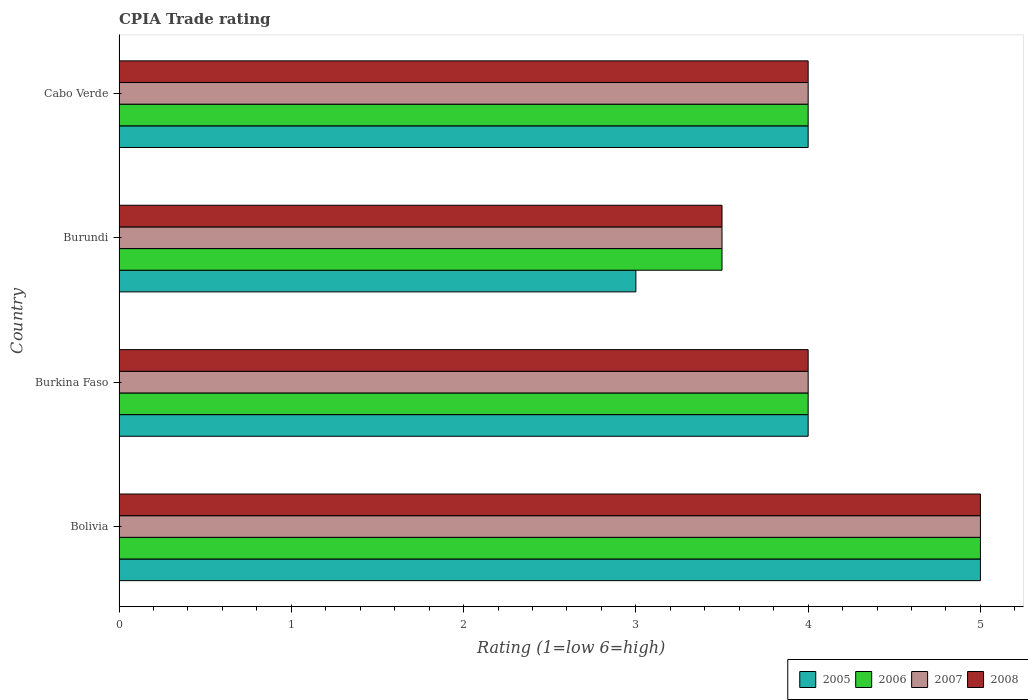How many groups of bars are there?
Ensure brevity in your answer.  4. Are the number of bars on each tick of the Y-axis equal?
Keep it short and to the point. Yes. How many bars are there on the 2nd tick from the bottom?
Offer a terse response. 4. What is the label of the 4th group of bars from the top?
Give a very brief answer. Bolivia. Across all countries, what is the minimum CPIA rating in 2005?
Give a very brief answer. 3. In which country was the CPIA rating in 2005 maximum?
Ensure brevity in your answer.  Bolivia. In which country was the CPIA rating in 2005 minimum?
Ensure brevity in your answer.  Burundi. What is the total CPIA rating in 2006 in the graph?
Offer a very short reply. 16.5. What is the difference between the CPIA rating in 2007 in Burkina Faso and that in Cabo Verde?
Provide a short and direct response. 0. What is the difference between the CPIA rating in 2005 in Bolivia and the CPIA rating in 2006 in Burkina Faso?
Your answer should be very brief. 1. What is the difference between the CPIA rating in 2007 and CPIA rating in 2006 in Bolivia?
Offer a terse response. 0. What is the ratio of the CPIA rating in 2007 in Burundi to that in Cabo Verde?
Your answer should be very brief. 0.88. Is the CPIA rating in 2007 in Burundi less than that in Cabo Verde?
Your response must be concise. Yes. What is the difference between the highest and the lowest CPIA rating in 2006?
Provide a succinct answer. 1.5. In how many countries, is the CPIA rating in 2007 greater than the average CPIA rating in 2007 taken over all countries?
Provide a short and direct response. 1. What does the 3rd bar from the bottom in Cabo Verde represents?
Your answer should be very brief. 2007. How many bars are there?
Your answer should be compact. 16. Are all the bars in the graph horizontal?
Make the answer very short. Yes. How many countries are there in the graph?
Keep it short and to the point. 4. What is the difference between two consecutive major ticks on the X-axis?
Give a very brief answer. 1. What is the title of the graph?
Offer a terse response. CPIA Trade rating. What is the label or title of the X-axis?
Your response must be concise. Rating (1=low 6=high). What is the label or title of the Y-axis?
Give a very brief answer. Country. What is the Rating (1=low 6=high) in 2005 in Burkina Faso?
Give a very brief answer. 4. What is the Rating (1=low 6=high) of 2005 in Burundi?
Give a very brief answer. 3. What is the Rating (1=low 6=high) in 2007 in Burundi?
Your answer should be compact. 3.5. What is the Rating (1=low 6=high) of 2008 in Burundi?
Your response must be concise. 3.5. What is the Rating (1=low 6=high) of 2005 in Cabo Verde?
Offer a very short reply. 4. Across all countries, what is the maximum Rating (1=low 6=high) in 2005?
Offer a terse response. 5. Across all countries, what is the maximum Rating (1=low 6=high) of 2007?
Provide a succinct answer. 5. Across all countries, what is the minimum Rating (1=low 6=high) of 2005?
Provide a succinct answer. 3. What is the total Rating (1=low 6=high) of 2007 in the graph?
Your response must be concise. 16.5. What is the total Rating (1=low 6=high) of 2008 in the graph?
Your response must be concise. 16.5. What is the difference between the Rating (1=low 6=high) of 2007 in Bolivia and that in Burkina Faso?
Your response must be concise. 1. What is the difference between the Rating (1=low 6=high) of 2005 in Bolivia and that in Burundi?
Offer a terse response. 2. What is the difference between the Rating (1=low 6=high) in 2007 in Bolivia and that in Burundi?
Keep it short and to the point. 1.5. What is the difference between the Rating (1=low 6=high) in 2007 in Bolivia and that in Cabo Verde?
Provide a succinct answer. 1. What is the difference between the Rating (1=low 6=high) of 2006 in Burkina Faso and that in Burundi?
Provide a succinct answer. 0.5. What is the difference between the Rating (1=low 6=high) in 2005 in Burundi and that in Cabo Verde?
Offer a very short reply. -1. What is the difference between the Rating (1=low 6=high) in 2006 in Burundi and that in Cabo Verde?
Your response must be concise. -0.5. What is the difference between the Rating (1=low 6=high) in 2007 in Burundi and that in Cabo Verde?
Offer a very short reply. -0.5. What is the difference between the Rating (1=low 6=high) in 2005 in Bolivia and the Rating (1=low 6=high) in 2007 in Burkina Faso?
Offer a terse response. 1. What is the difference between the Rating (1=low 6=high) in 2006 in Bolivia and the Rating (1=low 6=high) in 2007 in Burkina Faso?
Keep it short and to the point. 1. What is the difference between the Rating (1=low 6=high) in 2007 in Bolivia and the Rating (1=low 6=high) in 2008 in Burkina Faso?
Offer a terse response. 1. What is the difference between the Rating (1=low 6=high) of 2005 in Bolivia and the Rating (1=low 6=high) of 2006 in Burundi?
Your answer should be compact. 1.5. What is the difference between the Rating (1=low 6=high) of 2005 in Bolivia and the Rating (1=low 6=high) of 2008 in Burundi?
Offer a terse response. 1.5. What is the difference between the Rating (1=low 6=high) in 2007 in Bolivia and the Rating (1=low 6=high) in 2008 in Burundi?
Make the answer very short. 1.5. What is the difference between the Rating (1=low 6=high) of 2005 in Bolivia and the Rating (1=low 6=high) of 2006 in Cabo Verde?
Give a very brief answer. 1. What is the difference between the Rating (1=low 6=high) of 2005 in Bolivia and the Rating (1=low 6=high) of 2008 in Cabo Verde?
Your answer should be compact. 1. What is the difference between the Rating (1=low 6=high) in 2007 in Bolivia and the Rating (1=low 6=high) in 2008 in Cabo Verde?
Make the answer very short. 1. What is the difference between the Rating (1=low 6=high) in 2005 in Burkina Faso and the Rating (1=low 6=high) in 2007 in Burundi?
Provide a short and direct response. 0.5. What is the difference between the Rating (1=low 6=high) of 2005 in Burkina Faso and the Rating (1=low 6=high) of 2008 in Burundi?
Offer a very short reply. 0.5. What is the difference between the Rating (1=low 6=high) of 2006 in Burkina Faso and the Rating (1=low 6=high) of 2007 in Burundi?
Offer a terse response. 0.5. What is the difference between the Rating (1=low 6=high) of 2005 in Burkina Faso and the Rating (1=low 6=high) of 2007 in Cabo Verde?
Give a very brief answer. 0. What is the difference between the Rating (1=low 6=high) in 2005 in Burkina Faso and the Rating (1=low 6=high) in 2008 in Cabo Verde?
Offer a very short reply. 0. What is the difference between the Rating (1=low 6=high) in 2006 in Burkina Faso and the Rating (1=low 6=high) in 2007 in Cabo Verde?
Ensure brevity in your answer.  0. What is the difference between the Rating (1=low 6=high) of 2006 in Burkina Faso and the Rating (1=low 6=high) of 2008 in Cabo Verde?
Give a very brief answer. 0. What is the difference between the Rating (1=low 6=high) of 2007 in Burkina Faso and the Rating (1=low 6=high) of 2008 in Cabo Verde?
Offer a terse response. 0. What is the difference between the Rating (1=low 6=high) in 2005 in Burundi and the Rating (1=low 6=high) in 2006 in Cabo Verde?
Keep it short and to the point. -1. What is the difference between the Rating (1=low 6=high) in 2006 in Burundi and the Rating (1=low 6=high) in 2007 in Cabo Verde?
Provide a succinct answer. -0.5. What is the difference between the Rating (1=low 6=high) in 2007 in Burundi and the Rating (1=low 6=high) in 2008 in Cabo Verde?
Provide a succinct answer. -0.5. What is the average Rating (1=low 6=high) in 2006 per country?
Give a very brief answer. 4.12. What is the average Rating (1=low 6=high) of 2007 per country?
Give a very brief answer. 4.12. What is the average Rating (1=low 6=high) of 2008 per country?
Ensure brevity in your answer.  4.12. What is the difference between the Rating (1=low 6=high) of 2006 and Rating (1=low 6=high) of 2007 in Bolivia?
Offer a very short reply. 0. What is the difference between the Rating (1=low 6=high) of 2005 and Rating (1=low 6=high) of 2007 in Burkina Faso?
Provide a succinct answer. 0. What is the difference between the Rating (1=low 6=high) in 2005 and Rating (1=low 6=high) in 2008 in Burkina Faso?
Provide a short and direct response. 0. What is the difference between the Rating (1=low 6=high) in 2006 and Rating (1=low 6=high) in 2008 in Burkina Faso?
Give a very brief answer. 0. What is the difference between the Rating (1=low 6=high) in 2007 and Rating (1=low 6=high) in 2008 in Burkina Faso?
Your answer should be compact. 0. What is the difference between the Rating (1=low 6=high) of 2005 and Rating (1=low 6=high) of 2007 in Burundi?
Give a very brief answer. -0.5. What is the difference between the Rating (1=low 6=high) of 2005 and Rating (1=low 6=high) of 2008 in Burundi?
Your answer should be very brief. -0.5. What is the difference between the Rating (1=low 6=high) of 2007 and Rating (1=low 6=high) of 2008 in Burundi?
Provide a succinct answer. 0. What is the difference between the Rating (1=low 6=high) in 2006 and Rating (1=low 6=high) in 2007 in Cabo Verde?
Offer a terse response. 0. What is the difference between the Rating (1=low 6=high) in 2006 and Rating (1=low 6=high) in 2008 in Cabo Verde?
Keep it short and to the point. 0. What is the ratio of the Rating (1=low 6=high) of 2005 in Bolivia to that in Burkina Faso?
Make the answer very short. 1.25. What is the ratio of the Rating (1=low 6=high) in 2007 in Bolivia to that in Burkina Faso?
Make the answer very short. 1.25. What is the ratio of the Rating (1=low 6=high) in 2005 in Bolivia to that in Burundi?
Your answer should be very brief. 1.67. What is the ratio of the Rating (1=low 6=high) in 2006 in Bolivia to that in Burundi?
Ensure brevity in your answer.  1.43. What is the ratio of the Rating (1=low 6=high) of 2007 in Bolivia to that in Burundi?
Keep it short and to the point. 1.43. What is the ratio of the Rating (1=low 6=high) of 2008 in Bolivia to that in Burundi?
Provide a short and direct response. 1.43. What is the ratio of the Rating (1=low 6=high) of 2007 in Bolivia to that in Cabo Verde?
Your answer should be very brief. 1.25. What is the ratio of the Rating (1=low 6=high) in 2008 in Bolivia to that in Cabo Verde?
Offer a terse response. 1.25. What is the ratio of the Rating (1=low 6=high) of 2006 in Burkina Faso to that in Burundi?
Your answer should be compact. 1.14. What is the ratio of the Rating (1=low 6=high) in 2008 in Burkina Faso to that in Cabo Verde?
Ensure brevity in your answer.  1. What is the ratio of the Rating (1=low 6=high) of 2006 in Burundi to that in Cabo Verde?
Ensure brevity in your answer.  0.88. What is the difference between the highest and the second highest Rating (1=low 6=high) in 2005?
Your answer should be very brief. 1. What is the difference between the highest and the second highest Rating (1=low 6=high) in 2006?
Your response must be concise. 1. What is the difference between the highest and the lowest Rating (1=low 6=high) in 2006?
Offer a very short reply. 1.5. What is the difference between the highest and the lowest Rating (1=low 6=high) of 2007?
Your answer should be compact. 1.5. What is the difference between the highest and the lowest Rating (1=low 6=high) in 2008?
Your answer should be compact. 1.5. 